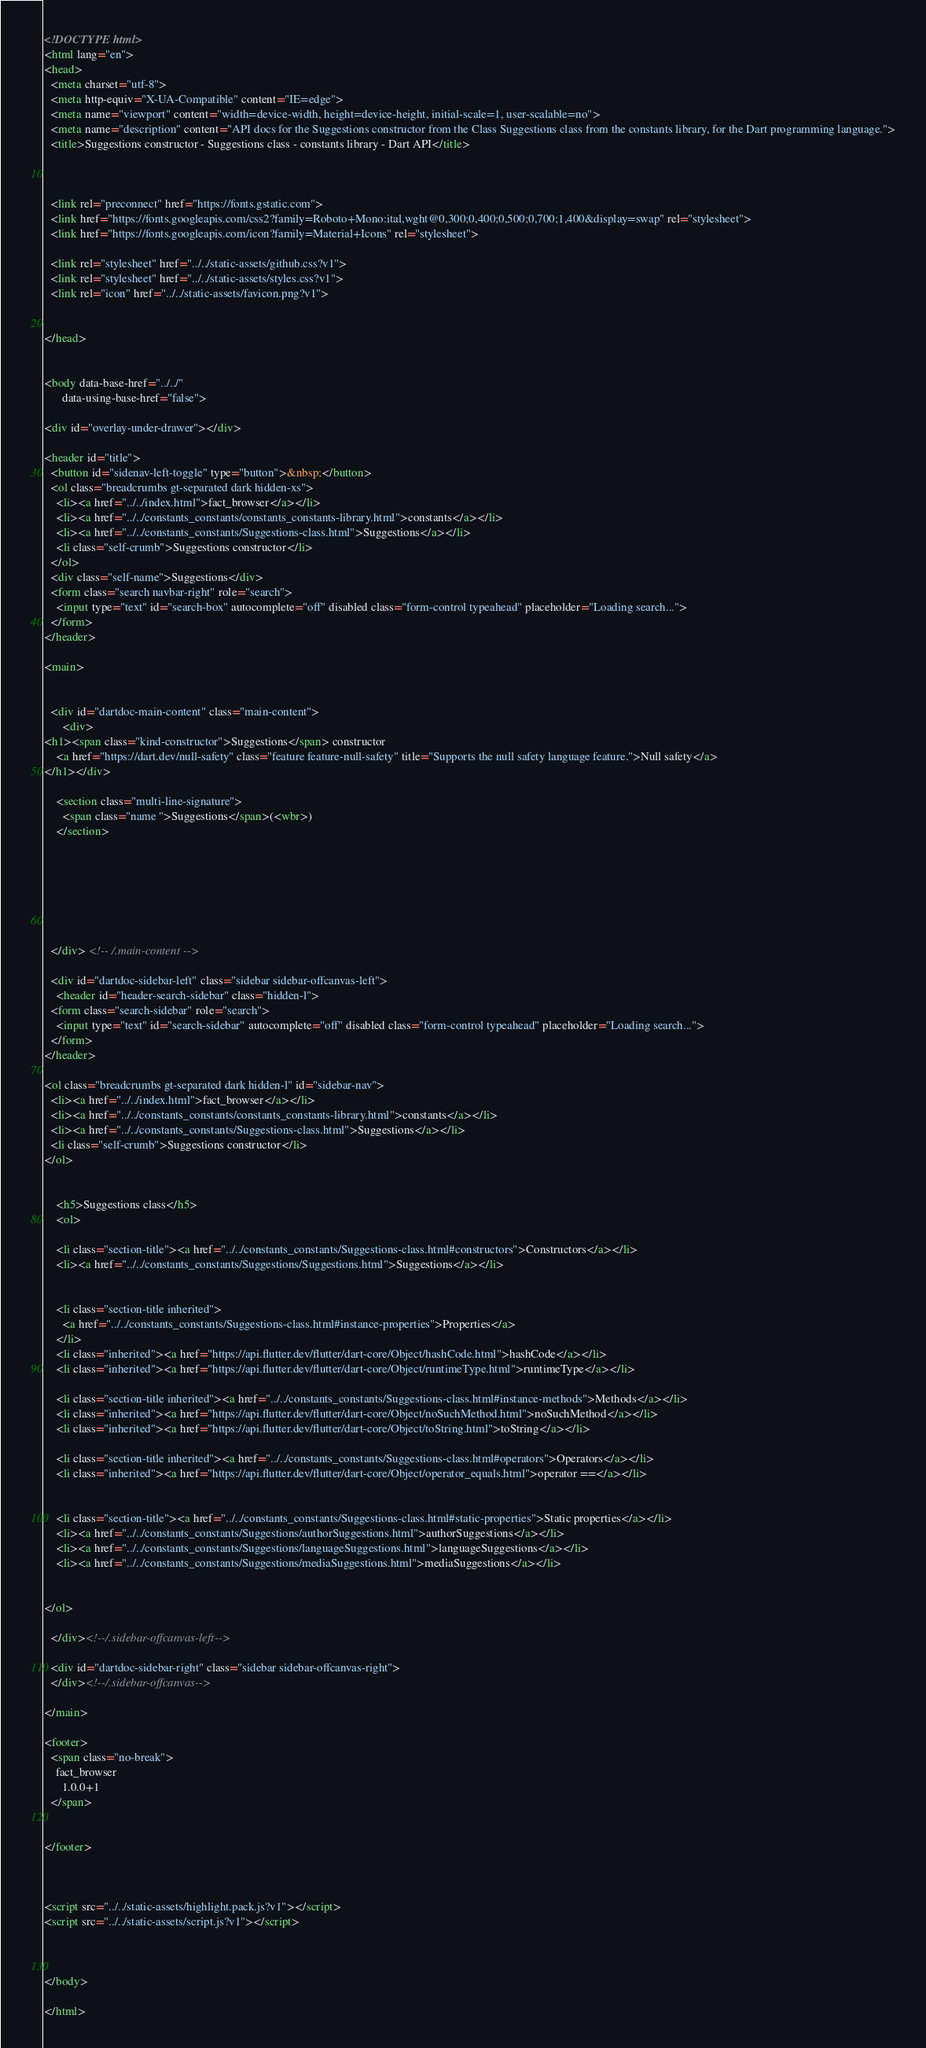Convert code to text. <code><loc_0><loc_0><loc_500><loc_500><_HTML_><!DOCTYPE html>
<html lang="en">
<head>
  <meta charset="utf-8">
  <meta http-equiv="X-UA-Compatible" content="IE=edge">
  <meta name="viewport" content="width=device-width, height=device-height, initial-scale=1, user-scalable=no">
  <meta name="description" content="API docs for the Suggestions constructor from the Class Suggestions class from the constants library, for the Dart programming language.">
  <title>Suggestions constructor - Suggestions class - constants library - Dart API</title>


  
  <link rel="preconnect" href="https://fonts.gstatic.com">
  <link href="https://fonts.googleapis.com/css2?family=Roboto+Mono:ital,wght@0,300;0,400;0,500;0,700;1,400&display=swap" rel="stylesheet">
  <link href="https://fonts.googleapis.com/icon?family=Material+Icons" rel="stylesheet">
  
  <link rel="stylesheet" href="../../static-assets/github.css?v1">
  <link rel="stylesheet" href="../../static-assets/styles.css?v1">
  <link rel="icon" href="../../static-assets/favicon.png?v1">

  
</head>


<body data-base-href="../../"
      data-using-base-href="false">

<div id="overlay-under-drawer"></div>

<header id="title">
  <button id="sidenav-left-toggle" type="button">&nbsp;</button>
  <ol class="breadcrumbs gt-separated dark hidden-xs">
    <li><a href="../../index.html">fact_browser</a></li>
    <li><a href="../../constants_constants/constants_constants-library.html">constants</a></li>
    <li><a href="../../constants_constants/Suggestions-class.html">Suggestions</a></li>
    <li class="self-crumb">Suggestions constructor</li>
  </ol>
  <div class="self-name">Suggestions</div>
  <form class="search navbar-right" role="search">
    <input type="text" id="search-box" autocomplete="off" disabled class="form-control typeahead" placeholder="Loading search...">
  </form>
</header>

<main>


  <div id="dartdoc-main-content" class="main-content">
      <div>
<h1><span class="kind-constructor">Suggestions</span> constructor 
    <a href="https://dart.dev/null-safety" class="feature feature-null-safety" title="Supports the null safety language feature.">Null safety</a>
</h1></div>

    <section class="multi-line-signature">
      <span class="name ">Suggestions</span>(<wbr>)
    </section>

    


    


  </div> <!-- /.main-content -->

  <div id="dartdoc-sidebar-left" class="sidebar sidebar-offcanvas-left">
    <header id="header-search-sidebar" class="hidden-l">
  <form class="search-sidebar" role="search">
    <input type="text" id="search-sidebar" autocomplete="off" disabled class="form-control typeahead" placeholder="Loading search...">
  </form>
</header>

<ol class="breadcrumbs gt-separated dark hidden-l" id="sidebar-nav">
  <li><a href="../../index.html">fact_browser</a></li>
  <li><a href="../../constants_constants/constants_constants-library.html">constants</a></li>
  <li><a href="../../constants_constants/Suggestions-class.html">Suggestions</a></li>
  <li class="self-crumb">Suggestions constructor</li>
</ol>


    <h5>Suggestions class</h5>
    <ol>

    <li class="section-title"><a href="../../constants_constants/Suggestions-class.html#constructors">Constructors</a></li>
    <li><a href="../../constants_constants/Suggestions/Suggestions.html">Suggestions</a></li>


    <li class="section-title inherited">
      <a href="../../constants_constants/Suggestions-class.html#instance-properties">Properties</a>
    </li>
    <li class="inherited"><a href="https://api.flutter.dev/flutter/dart-core/Object/hashCode.html">hashCode</a></li>
    <li class="inherited"><a href="https://api.flutter.dev/flutter/dart-core/Object/runtimeType.html">runtimeType</a></li>

    <li class="section-title inherited"><a href="../../constants_constants/Suggestions-class.html#instance-methods">Methods</a></li>
    <li class="inherited"><a href="https://api.flutter.dev/flutter/dart-core/Object/noSuchMethod.html">noSuchMethod</a></li>
    <li class="inherited"><a href="https://api.flutter.dev/flutter/dart-core/Object/toString.html">toString</a></li>

    <li class="section-title inherited"><a href="../../constants_constants/Suggestions-class.html#operators">Operators</a></li>
    <li class="inherited"><a href="https://api.flutter.dev/flutter/dart-core/Object/operator_equals.html">operator ==</a></li>


    <li class="section-title"><a href="../../constants_constants/Suggestions-class.html#static-properties">Static properties</a></li>
    <li><a href="../../constants_constants/Suggestions/authorSuggestions.html">authorSuggestions</a></li>
    <li><a href="../../constants_constants/Suggestions/languageSuggestions.html">languageSuggestions</a></li>
    <li><a href="../../constants_constants/Suggestions/mediaSuggestions.html">mediaSuggestions</a></li>


</ol>

  </div><!--/.sidebar-offcanvas-left-->

  <div id="dartdoc-sidebar-right" class="sidebar sidebar-offcanvas-right">
  </div><!--/.sidebar-offcanvas-->

</main>

<footer>
  <span class="no-break">
    fact_browser
      1.0.0+1
  </span>

  
</footer>



<script src="../../static-assets/highlight.pack.js?v1"></script>
<script src="../../static-assets/script.js?v1"></script>



</body>

</html>

</code> 